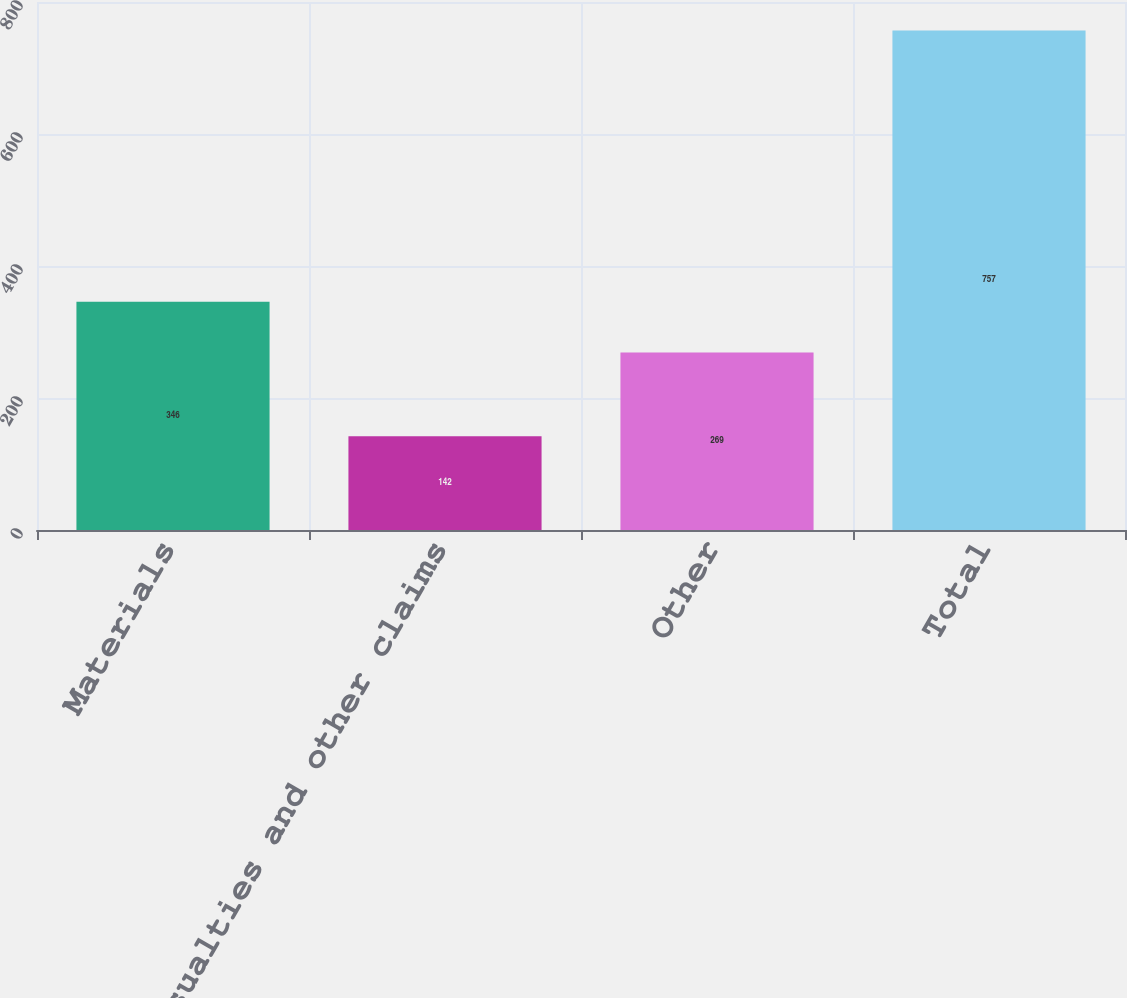Convert chart. <chart><loc_0><loc_0><loc_500><loc_500><bar_chart><fcel>Materials<fcel>Casualties and other claims<fcel>Other<fcel>Total<nl><fcel>346<fcel>142<fcel>269<fcel>757<nl></chart> 